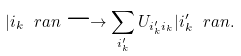Convert formula to latex. <formula><loc_0><loc_0><loc_500><loc_500>| i _ { k } \ r a n \longrightarrow \sum _ { i _ { k } ^ { \prime } } U _ { i _ { k } ^ { \prime } i _ { k } } | i _ { k } ^ { \prime } \ r a n .</formula> 